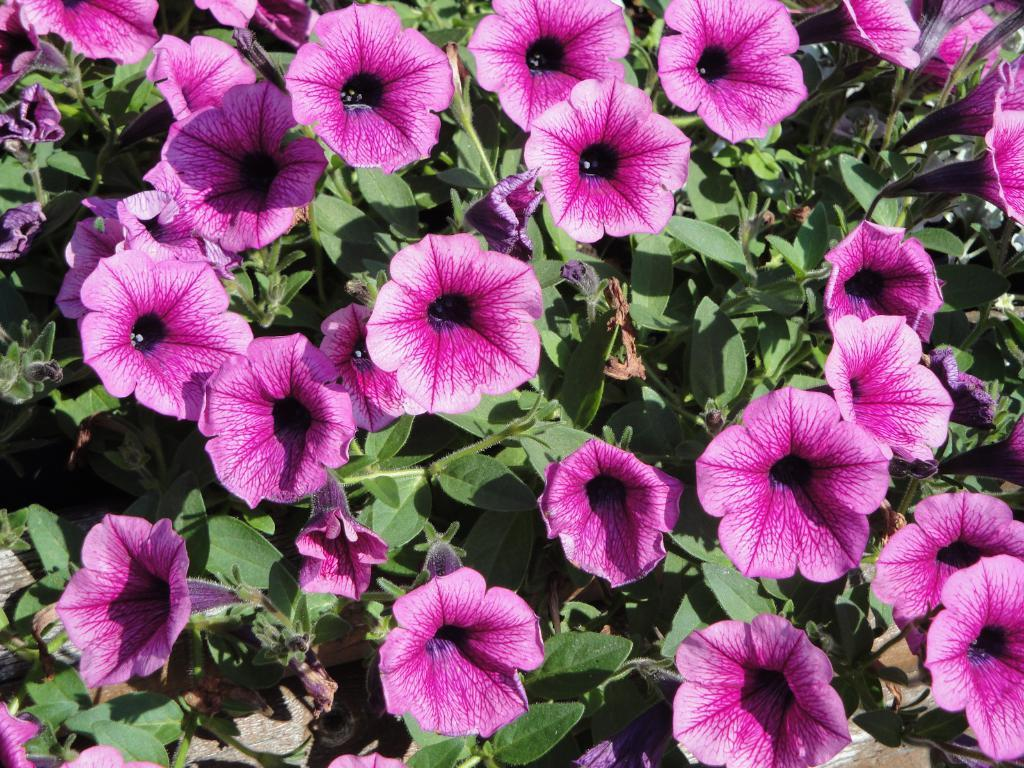What is the main subject of the image? The main subject of the image is a bunch of flowers. Can you describe the flowers in more detail? The flowers include leaves and stems. What is the background of the image? The ground is visible in the image. Where is the library located in the image? There is no library present in the image; it features a bunch of flowers. How many copies of the flowers can be seen in the image? There is only one bunch of flowers visible in the image, so there is no need for copies. 